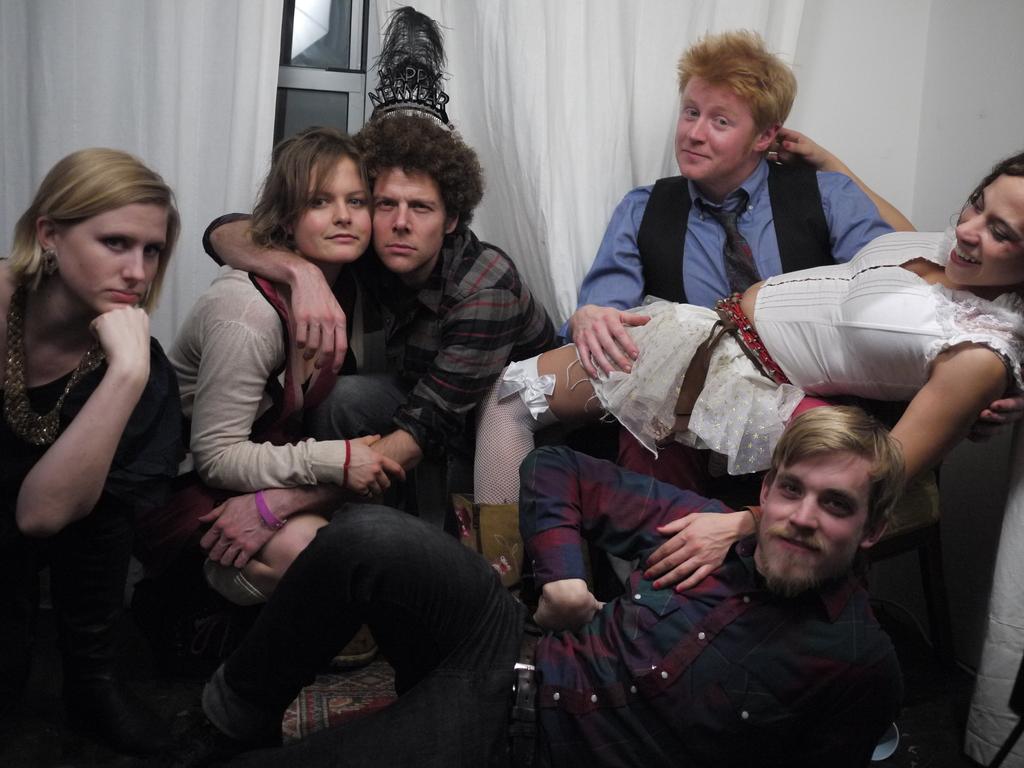How would you summarize this image in a sentence or two? In this image we can see many persons sitting on the ground. In the background we can see window, wall and curtains. 